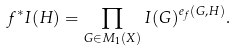Convert formula to latex. <formula><loc_0><loc_0><loc_500><loc_500>f ^ { * } I ( H ) = \prod _ { G \in M _ { 1 } ( X ) } I ( G ) ^ { e _ { f } ( G , H ) } .</formula> 